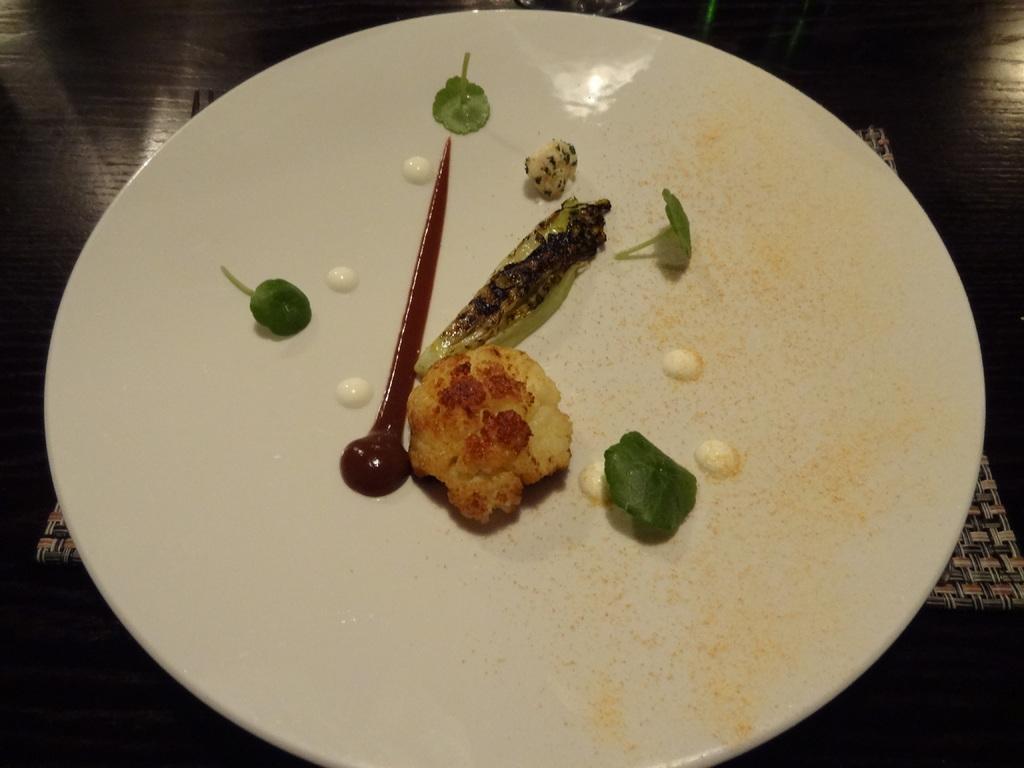Describe this image in one or two sentences. In this image we can see some food items in the plate. In the background of the image there is an object and dark view. 